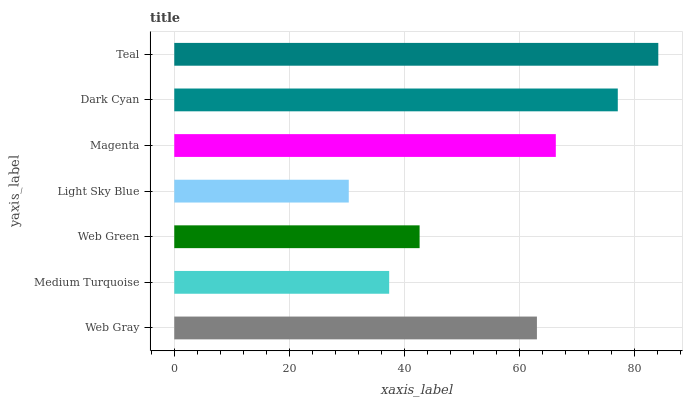Is Light Sky Blue the minimum?
Answer yes or no. Yes. Is Teal the maximum?
Answer yes or no. Yes. Is Medium Turquoise the minimum?
Answer yes or no. No. Is Medium Turquoise the maximum?
Answer yes or no. No. Is Web Gray greater than Medium Turquoise?
Answer yes or no. Yes. Is Medium Turquoise less than Web Gray?
Answer yes or no. Yes. Is Medium Turquoise greater than Web Gray?
Answer yes or no. No. Is Web Gray less than Medium Turquoise?
Answer yes or no. No. Is Web Gray the high median?
Answer yes or no. Yes. Is Web Gray the low median?
Answer yes or no. Yes. Is Web Green the high median?
Answer yes or no. No. Is Medium Turquoise the low median?
Answer yes or no. No. 